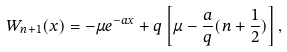Convert formula to latex. <formula><loc_0><loc_0><loc_500><loc_500>W _ { n + 1 } ( x ) = - \mu e ^ { - a x } + q \left [ \mu - \frac { a } { q } ( n + \frac { 1 } { 2 } ) \right ] ,</formula> 